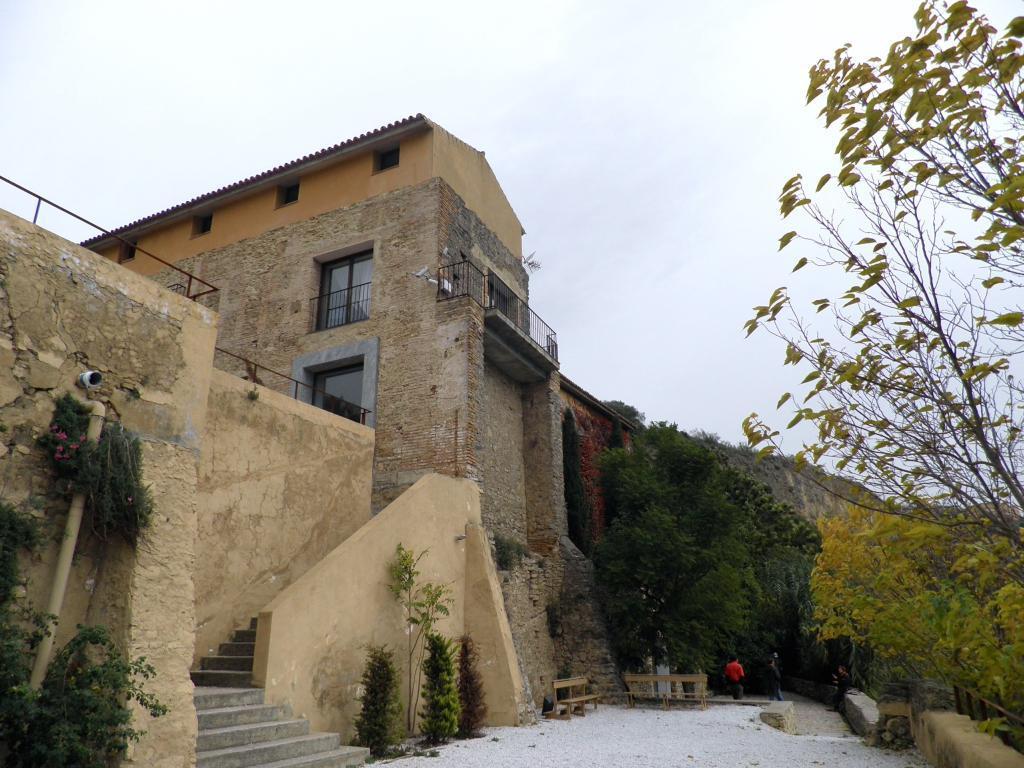How would you summarize this image in a sentence or two? In the center of the image there is a building. At the bottom there are bushes and trees. We can see people. There are benches. At the top there is sky. 